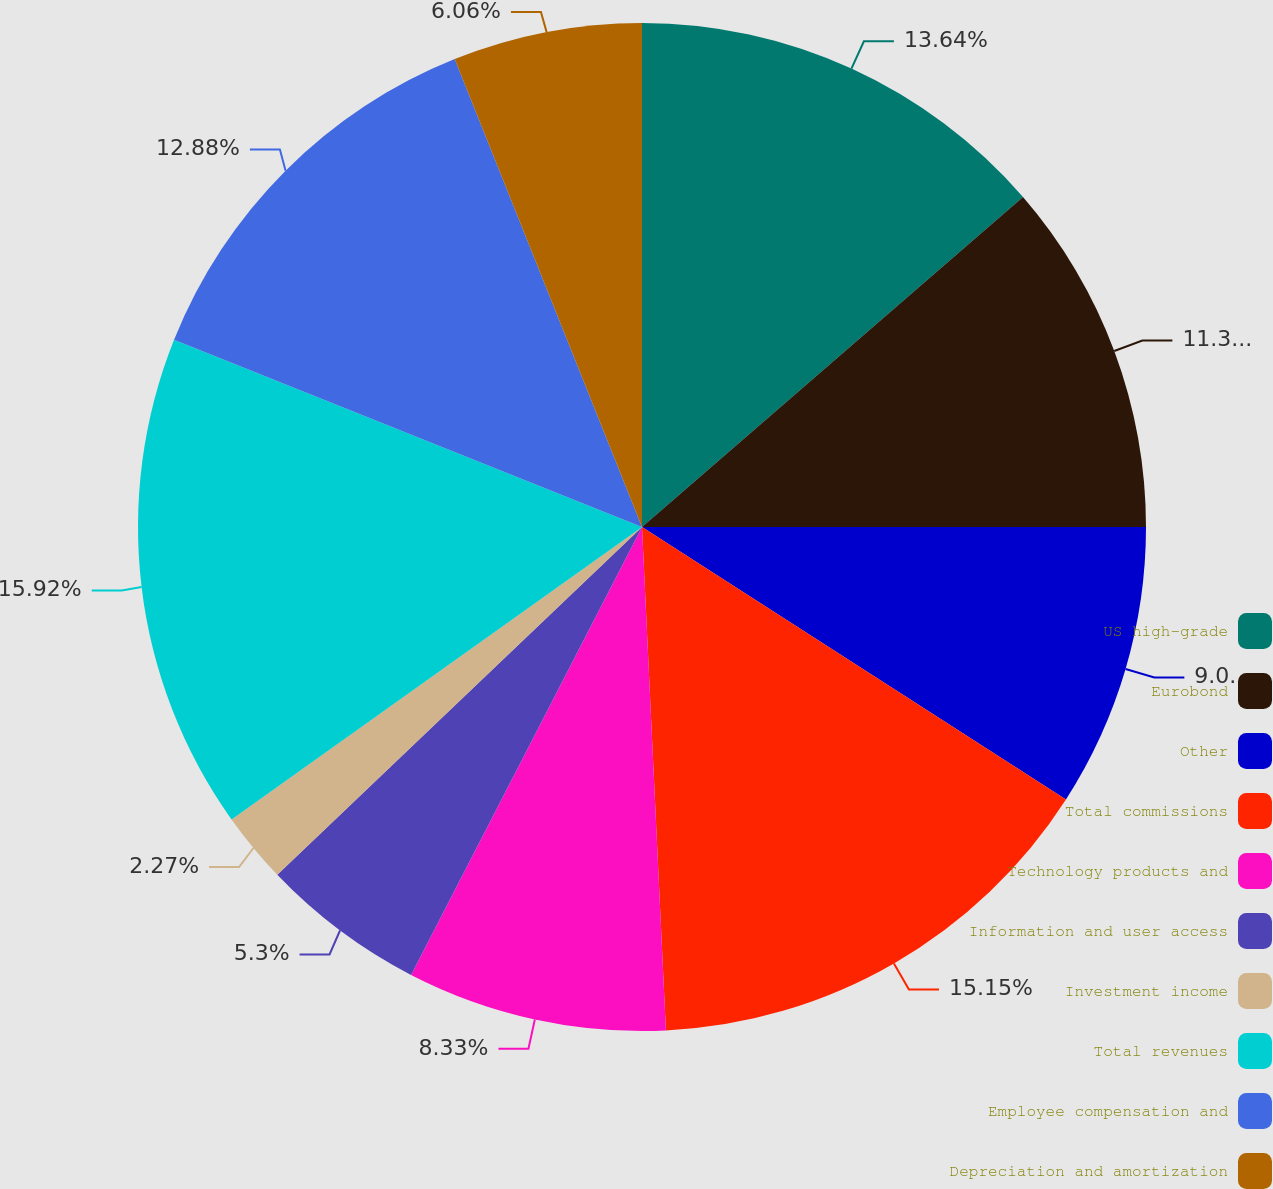<chart> <loc_0><loc_0><loc_500><loc_500><pie_chart><fcel>US high-grade<fcel>Eurobond<fcel>Other<fcel>Total commissions<fcel>Technology products and<fcel>Information and user access<fcel>Investment income<fcel>Total revenues<fcel>Employee compensation and<fcel>Depreciation and amortization<nl><fcel>13.64%<fcel>11.36%<fcel>9.09%<fcel>15.15%<fcel>8.33%<fcel>5.3%<fcel>2.27%<fcel>15.91%<fcel>12.88%<fcel>6.06%<nl></chart> 